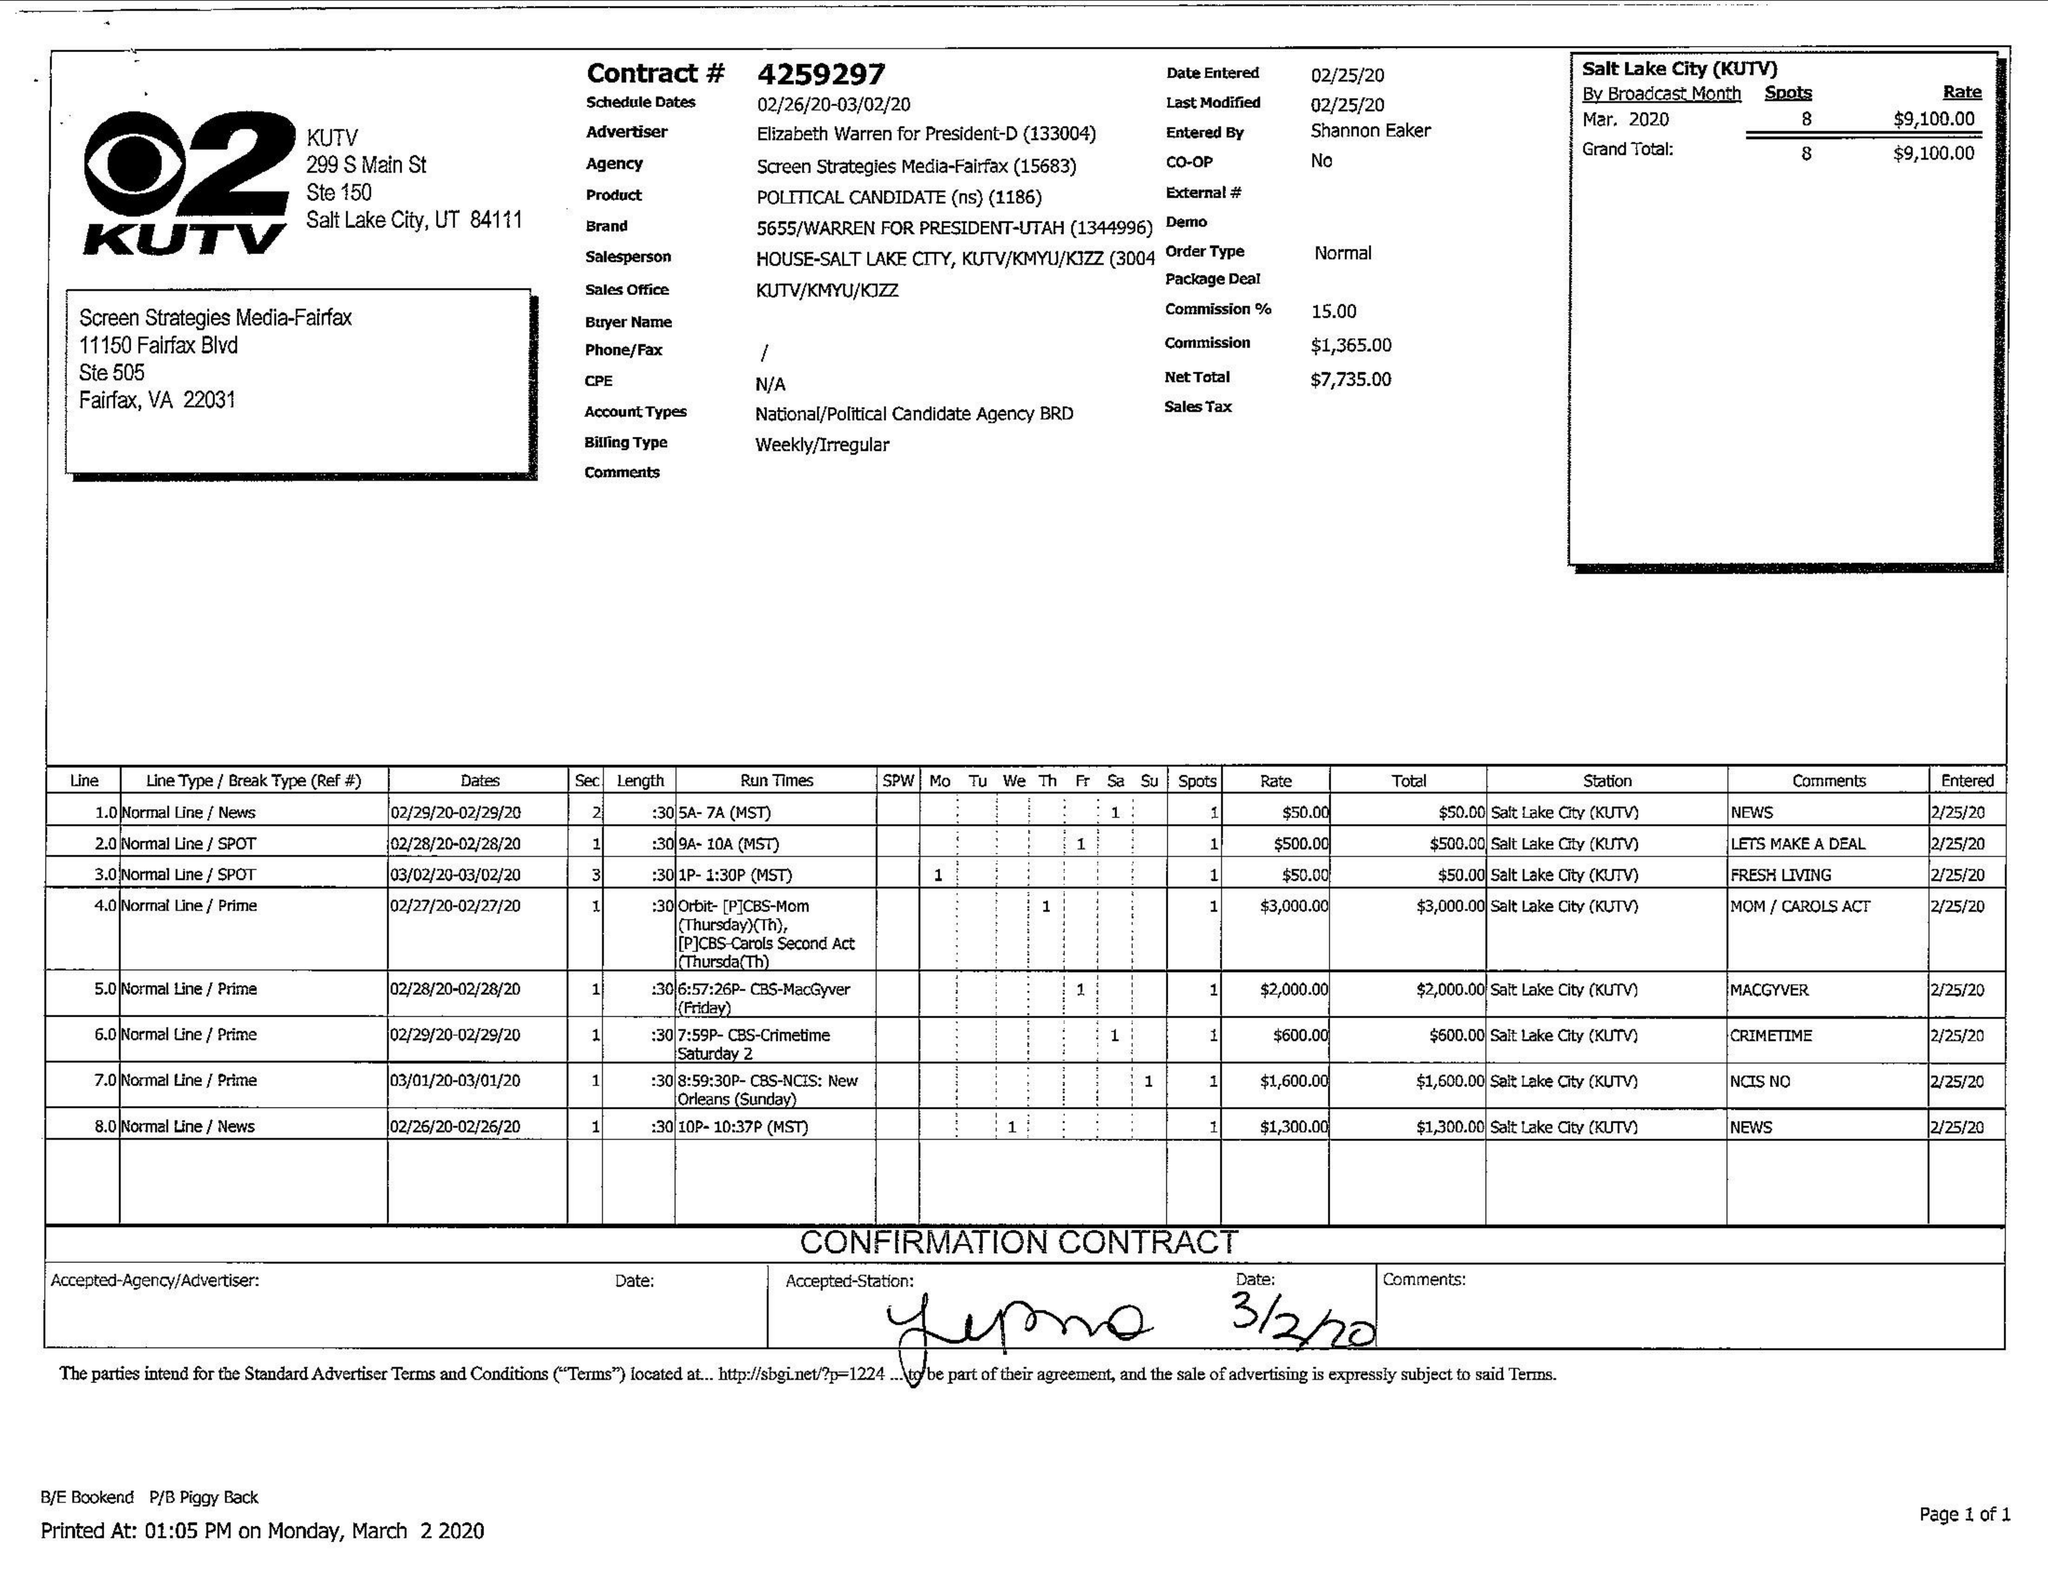What is the value for the flight_from?
Answer the question using a single word or phrase. 02/26/20 